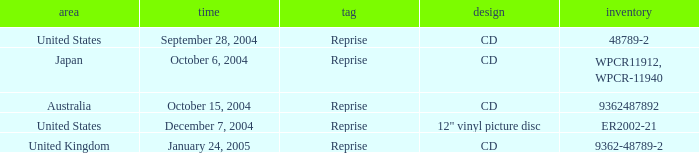Name the catalogue for australia 9362487892.0. 